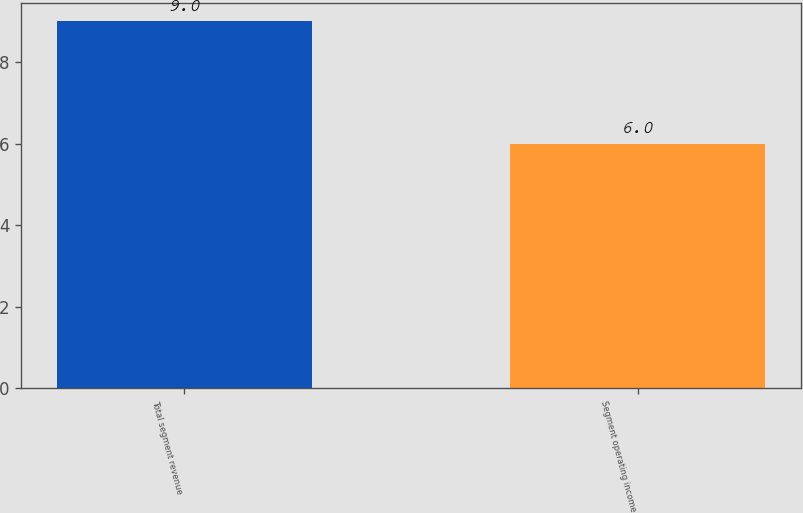Convert chart. <chart><loc_0><loc_0><loc_500><loc_500><bar_chart><fcel>Total segment revenue<fcel>Segment operating income<nl><fcel>9<fcel>6<nl></chart> 